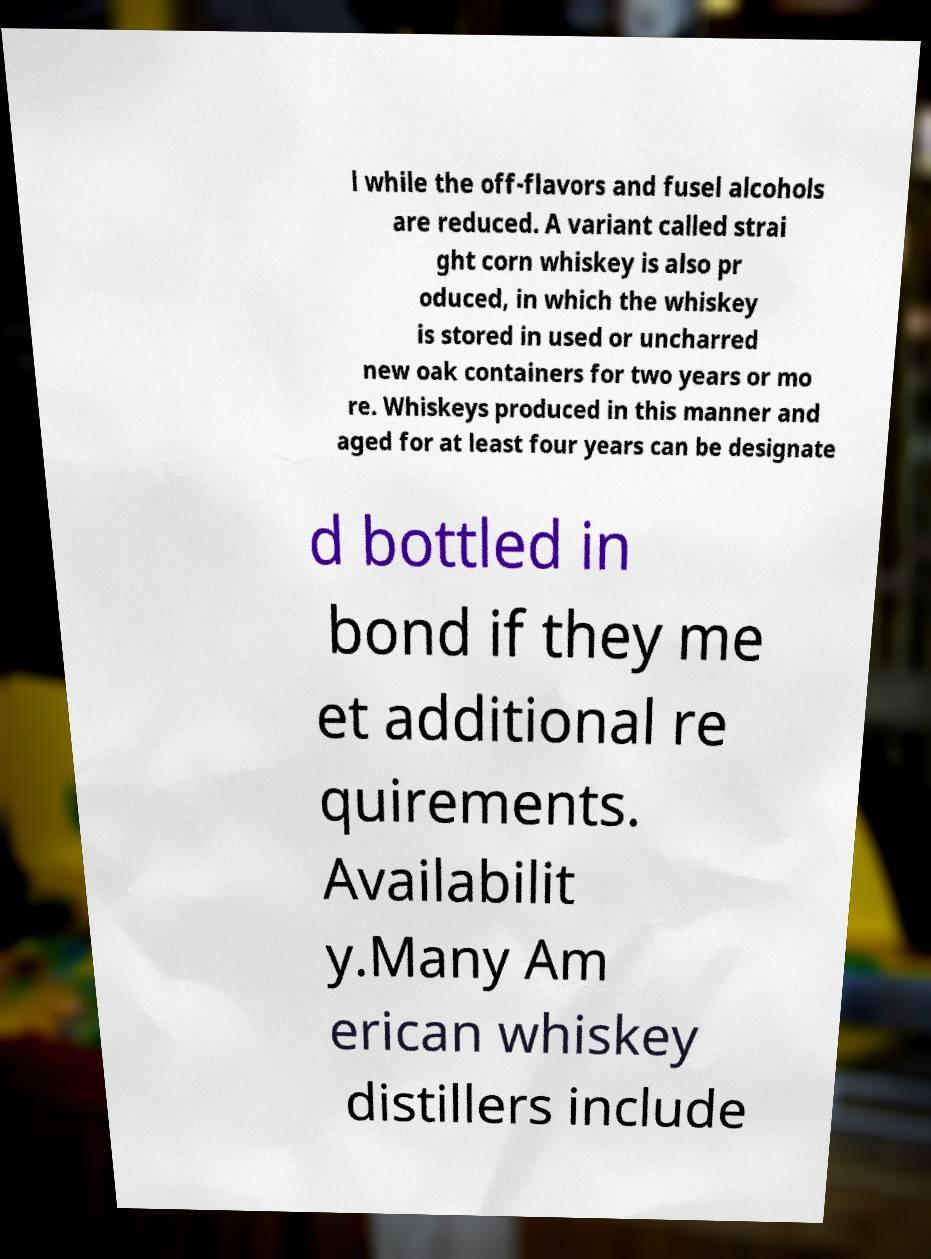For documentation purposes, I need the text within this image transcribed. Could you provide that? l while the off-flavors and fusel alcohols are reduced. A variant called strai ght corn whiskey is also pr oduced, in which the whiskey is stored in used or uncharred new oak containers for two years or mo re. Whiskeys produced in this manner and aged for at least four years can be designate d bottled in bond if they me et additional re quirements. Availabilit y.Many Am erican whiskey distillers include 